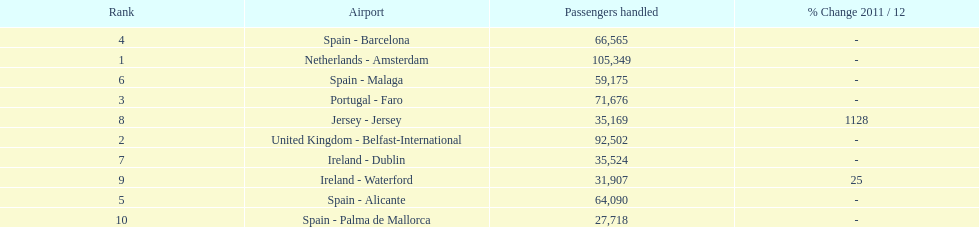How many passengers did the united kingdom handle? 92,502. Who handled more passengers than this? Netherlands - Amsterdam. 